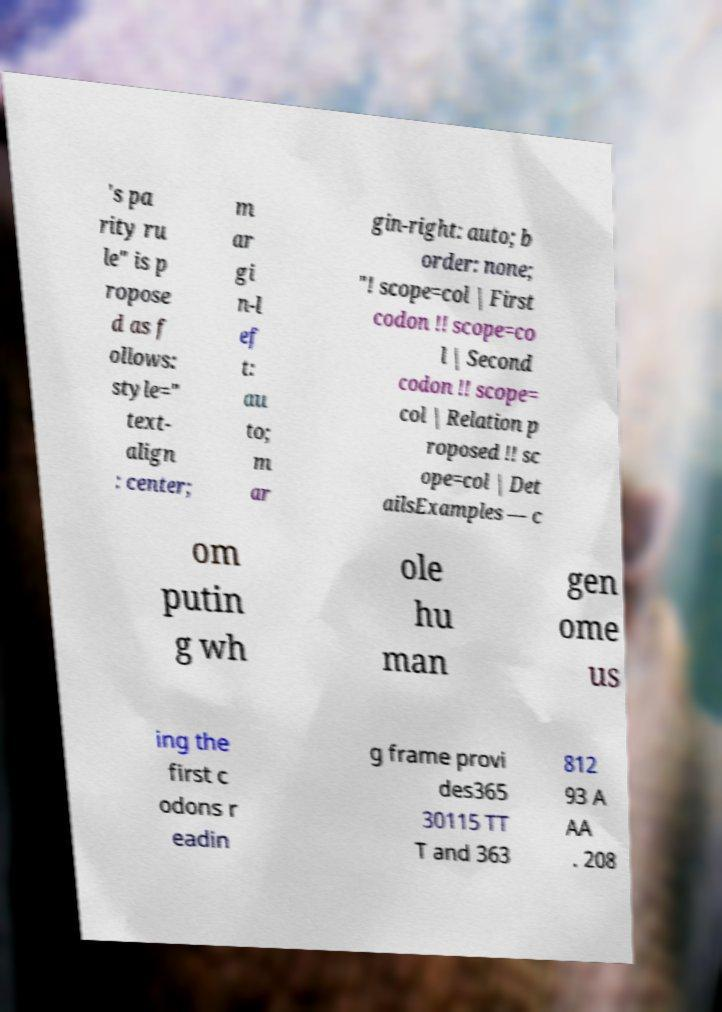I need the written content from this picture converted into text. Can you do that? 's pa rity ru le" is p ropose d as f ollows: style=" text- align : center; m ar gi n-l ef t: au to; m ar gin-right: auto; b order: none; "! scope=col | First codon !! scope=co l | Second codon !! scope= col | Relation p roposed !! sc ope=col | Det ailsExamples — c om putin g wh ole hu man gen ome us ing the first c odons r eadin g frame provi des365 30115 TT T and 363 812 93 A AA . 208 